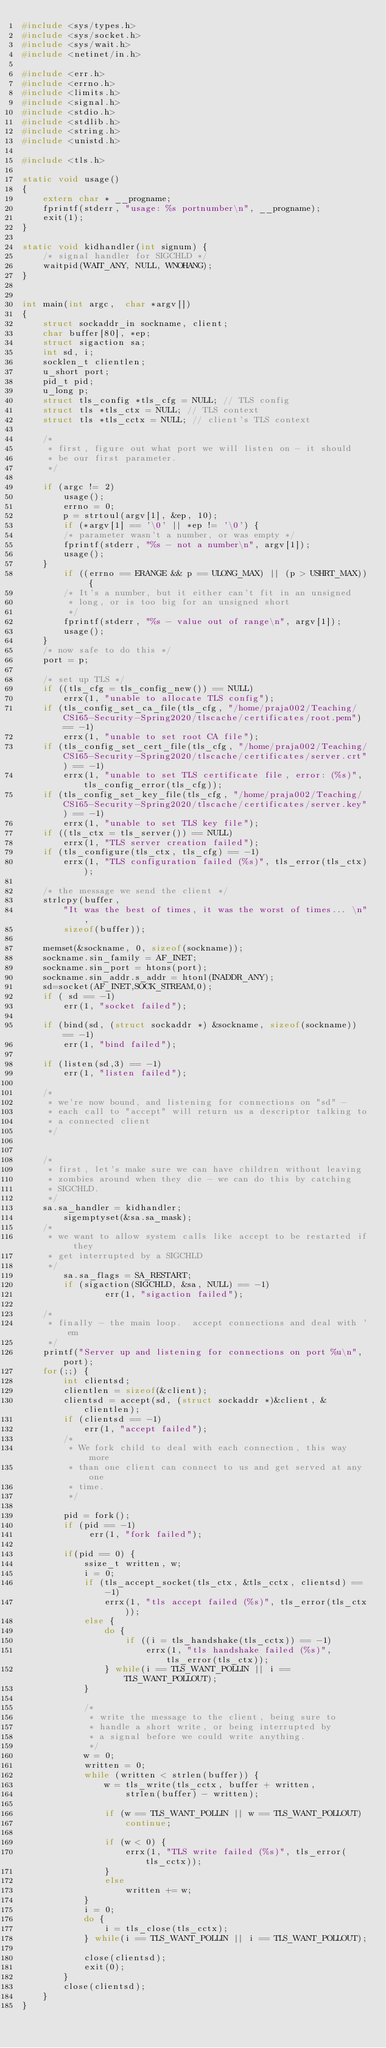Convert code to text. <code><loc_0><loc_0><loc_500><loc_500><_C_>#include <sys/types.h>
#include <sys/socket.h>
#include <sys/wait.h>
#include <netinet/in.h>

#include <err.h>
#include <errno.h>
#include <limits.h>
#include <signal.h>
#include <stdio.h>
#include <stdlib.h>
#include <string.h>
#include <unistd.h>

#include <tls.h>

static void usage()
{
	extern char * __progname;
	fprintf(stderr, "usage: %s portnumber\n", __progname);
	exit(1);
}

static void kidhandler(int signum) {
	/* signal handler for SIGCHLD */
	waitpid(WAIT_ANY, NULL, WNOHANG);
}


int main(int argc,  char *argv[])
{
	struct sockaddr_in sockname, client;
	char buffer[80], *ep;
	struct sigaction sa;
	int sd, i;
	socklen_t clientlen;
	u_short port;
	pid_t pid;
	u_long p;
	struct tls_config *tls_cfg = NULL; // TLS config
	struct tls *tls_ctx = NULL; // TLS context
	struct tls *tls_cctx = NULL; // client's TLS context

	/*
	 * first, figure out what port we will listen on - it should
	 * be our first parameter.
	 */

	if (argc != 2)
		usage();
		errno = 0;
        p = strtoul(argv[1], &ep, 10);
        if (*argv[1] == '\0' || *ep != '\0') {
		/* parameter wasn't a number, or was empty */
		fprintf(stderr, "%s - not a number\n", argv[1]);
		usage();
	}
        if ((errno == ERANGE && p == ULONG_MAX) || (p > USHRT_MAX)) {
		/* It's a number, but it either can't fit in an unsigned
		 * long, or is too big for an unsigned short
		 */
		fprintf(stderr, "%s - value out of range\n", argv[1]);
		usage();
	}
	/* now safe to do this */
	port = p;

	/* set up TLS */
	if ((tls_cfg = tls_config_new()) == NULL)
		errx(1, "unable to allocate TLS config");
	if (tls_config_set_ca_file(tls_cfg, "/home/praja002/Teaching/CS165-Security-Spring2020/tlscache/certificates/root.pem") == -1)
		errx(1, "unable to set root CA file");
	if (tls_config_set_cert_file(tls_cfg, "/home/praja002/Teaching/CS165-Security-Spring2020/tlscache/certificates/server.crt") == -1) 
		errx(1, "unable to set TLS certificate file, error: (%s)", tls_config_error(tls_cfg));
	if (tls_config_set_key_file(tls_cfg, "/home/praja002/Teaching/CS165-Security-Spring2020/tlscache/certificates/server.key") == -1)
		errx(1, "unable to set TLS key file");
	if ((tls_ctx = tls_server()) == NULL)
		errx(1, "TLS server creation failed");
	if (tls_configure(tls_ctx, tls_cfg) == -1)
		errx(1, "TLS configuration failed (%s)", tls_error(tls_ctx));

	/* the message we send the client */
	strlcpy(buffer,
	    "It was the best of times, it was the worst of times... \n",
	    sizeof(buffer));

	memset(&sockname, 0, sizeof(sockname));
	sockname.sin_family = AF_INET;
	sockname.sin_port = htons(port);
	sockname.sin_addr.s_addr = htonl(INADDR_ANY);
	sd=socket(AF_INET,SOCK_STREAM,0);
	if ( sd == -1)
		err(1, "socket failed");

	if (bind(sd, (struct sockaddr *) &sockname, sizeof(sockname)) == -1)
		err(1, "bind failed");

	if (listen(sd,3) == -1)
		err(1, "listen failed");

	/*
	 * we're now bound, and listening for connections on "sd" -
	 * each call to "accept" will return us a descriptor talking to
	 * a connected client
	 */


	/*
	 * first, let's make sure we can have children without leaving
	 * zombies around when they die - we can do this by catching
	 * SIGCHLD.
	 */
	sa.sa_handler = kidhandler;
        sigemptyset(&sa.sa_mask);
	/*
	 * we want to allow system calls like accept to be restarted if they
	 * get interrupted by a SIGCHLD
	 */
        sa.sa_flags = SA_RESTART;
        if (sigaction(SIGCHLD, &sa, NULL) == -1)
                err(1, "sigaction failed");

	/*
	 * finally - the main loop.  accept connections and deal with 'em
	 */
	printf("Server up and listening for connections on port %u\n", port);
	for(;;) {
		int clientsd;
		clientlen = sizeof(&client);
		clientsd = accept(sd, (struct sockaddr *)&client, &clientlen);
		if (clientsd == -1)
			err(1, "accept failed");
		/*
		 * We fork child to deal with each connection, this way more
		 * than one client can connect to us and get served at any one
		 * time.
		 */

		pid = fork();
		if (pid == -1)
		     err(1, "fork failed");

		if(pid == 0) {
			ssize_t written, w;
			i = 0;
			if (tls_accept_socket(tls_ctx, &tls_cctx, clientsd) == -1)
				errx(1, "tls accept failed (%s)", tls_error(tls_ctx));
			else {
				do {
					if ((i = tls_handshake(tls_cctx)) == -1)
						errx(1, "tls handshake failed (%s)", tls_error(tls_ctx));
				} while(i == TLS_WANT_POLLIN || i == TLS_WANT_POLLOUT);
			}

			/*
			 * write the message to the client, being sure to
			 * handle a short write, or being interrupted by
			 * a signal before we could write anything.
			 */
			w = 0;
			written = 0;
			while (written < strlen(buffer)) {
				w = tls_write(tls_cctx, buffer + written,
				    strlen(buffer) - written);

				if (w == TLS_WANT_POLLIN || w == TLS_WANT_POLLOUT)
					continue;

				if (w < 0) {
					errx(1, "TLS write failed (%s)", tls_error(tls_cctx));
				}
				else
					written += w;
			}
			i = 0;
			do {
				i = tls_close(tls_cctx);
			} while(i == TLS_WANT_POLLIN || i == TLS_WANT_POLLOUT);

			close(clientsd);
			exit(0);
		}
		close(clientsd);
	}
}
</code> 